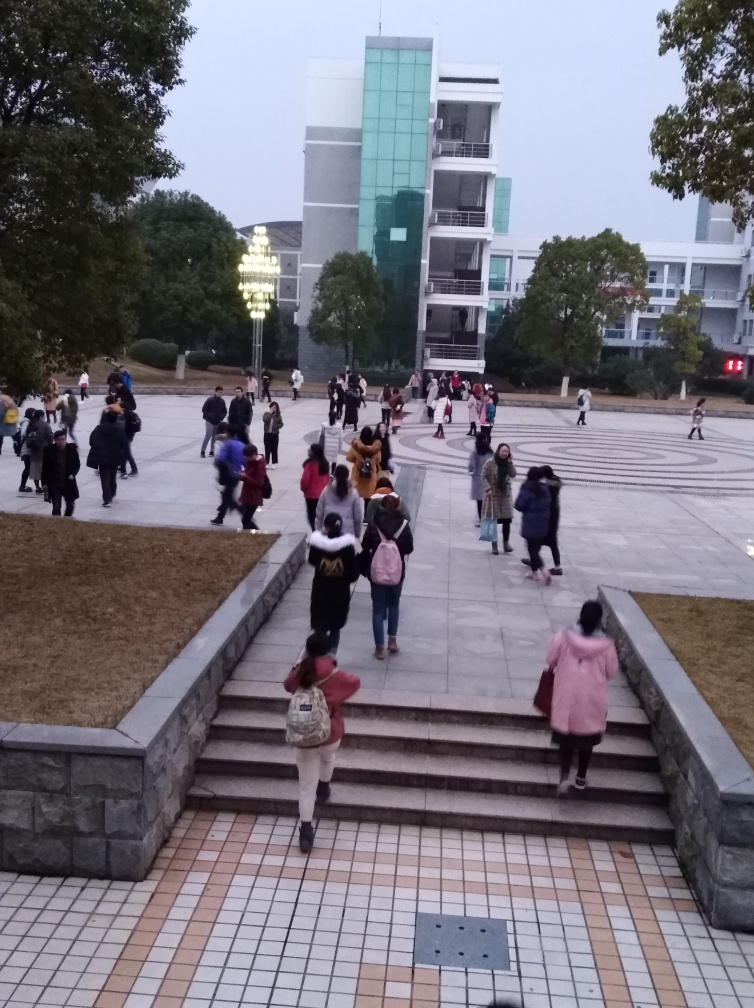What activity seems to be occurring in the image? The image captures a scene of people, possibly students, traversing a large open plaza. Many of them are ascending or descending a wide staircase, indicating it could be between class times at a university or another educational institution. Is there anything interesting about the way people are dressed? The individuals in the image are dressed in casual and varied attire. There are no uniforms, indicating a diverse and informal gathering, which is consistent with the character of a college campus. The attire also suggests a cooler weather, as many are wearing jackets or long sleeves. 